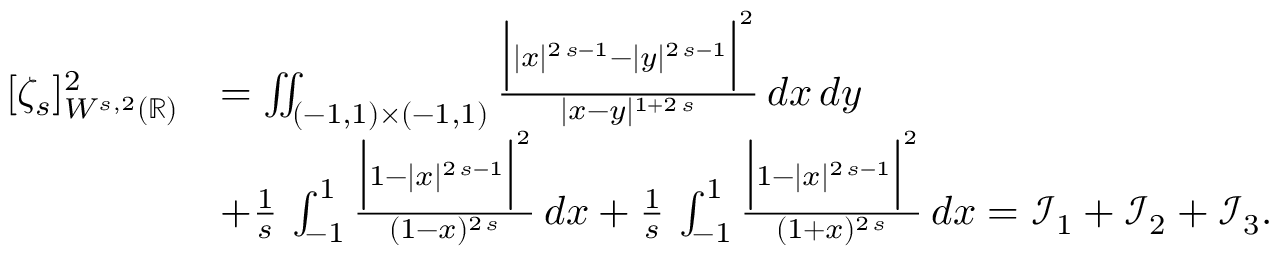Convert formula to latex. <formula><loc_0><loc_0><loc_500><loc_500>\begin{array} { r l } { [ \zeta _ { s } ] _ { W ^ { s , 2 } ( \mathbb { R } ) } ^ { 2 } } & { = \iint _ { ( - 1 , 1 ) \times ( - 1 , 1 ) } \frac { \left | | x | ^ { 2 \, s - 1 } - | y | ^ { 2 \, s - 1 } \right | ^ { 2 } } { | x - y | ^ { 1 + 2 \, s } } \, d x \, d y } \\ & { + \frac { 1 } { s } \, \int _ { - 1 } ^ { 1 } \frac { \left | 1 - | x | ^ { 2 \, s - 1 } \right | ^ { 2 } } { ( 1 - x ) ^ { 2 \, s } } \, d x + \frac { 1 } { s } \, \int _ { - 1 } ^ { 1 } \frac { \left | 1 - | x | ^ { 2 \, s - 1 } \right | ^ { 2 } } { ( 1 + x ) ^ { 2 \, s } } \, d x = \mathcal { I } _ { 1 } + \mathcal { I } _ { 2 } + \mathcal { I } _ { 3 } . } \end{array}</formula> 